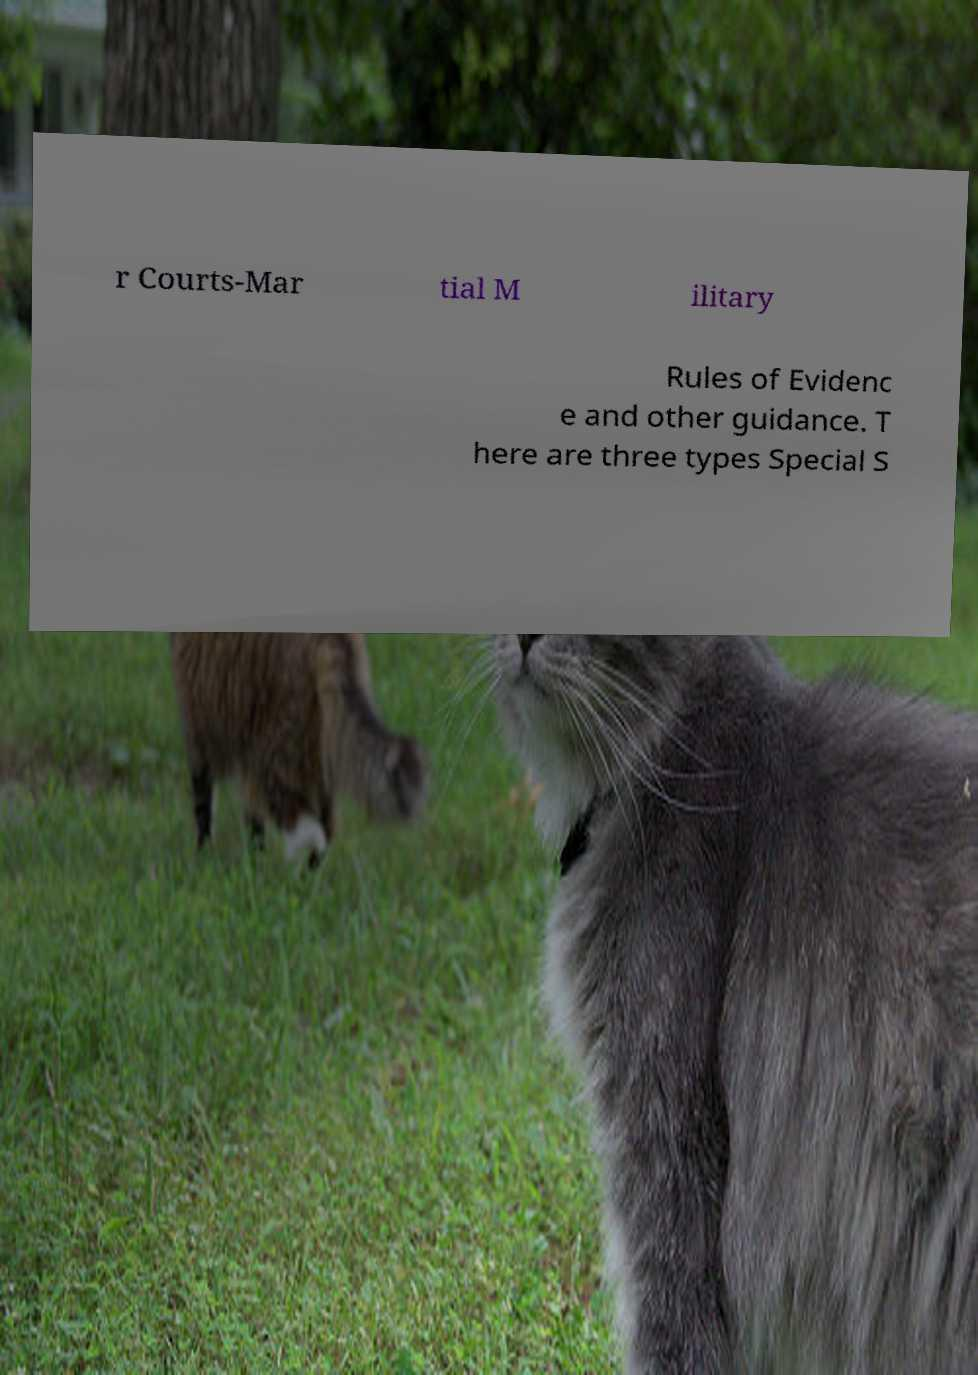Can you accurately transcribe the text from the provided image for me? r Courts-Mar tial M ilitary Rules of Evidenc e and other guidance. T here are three types Special S 